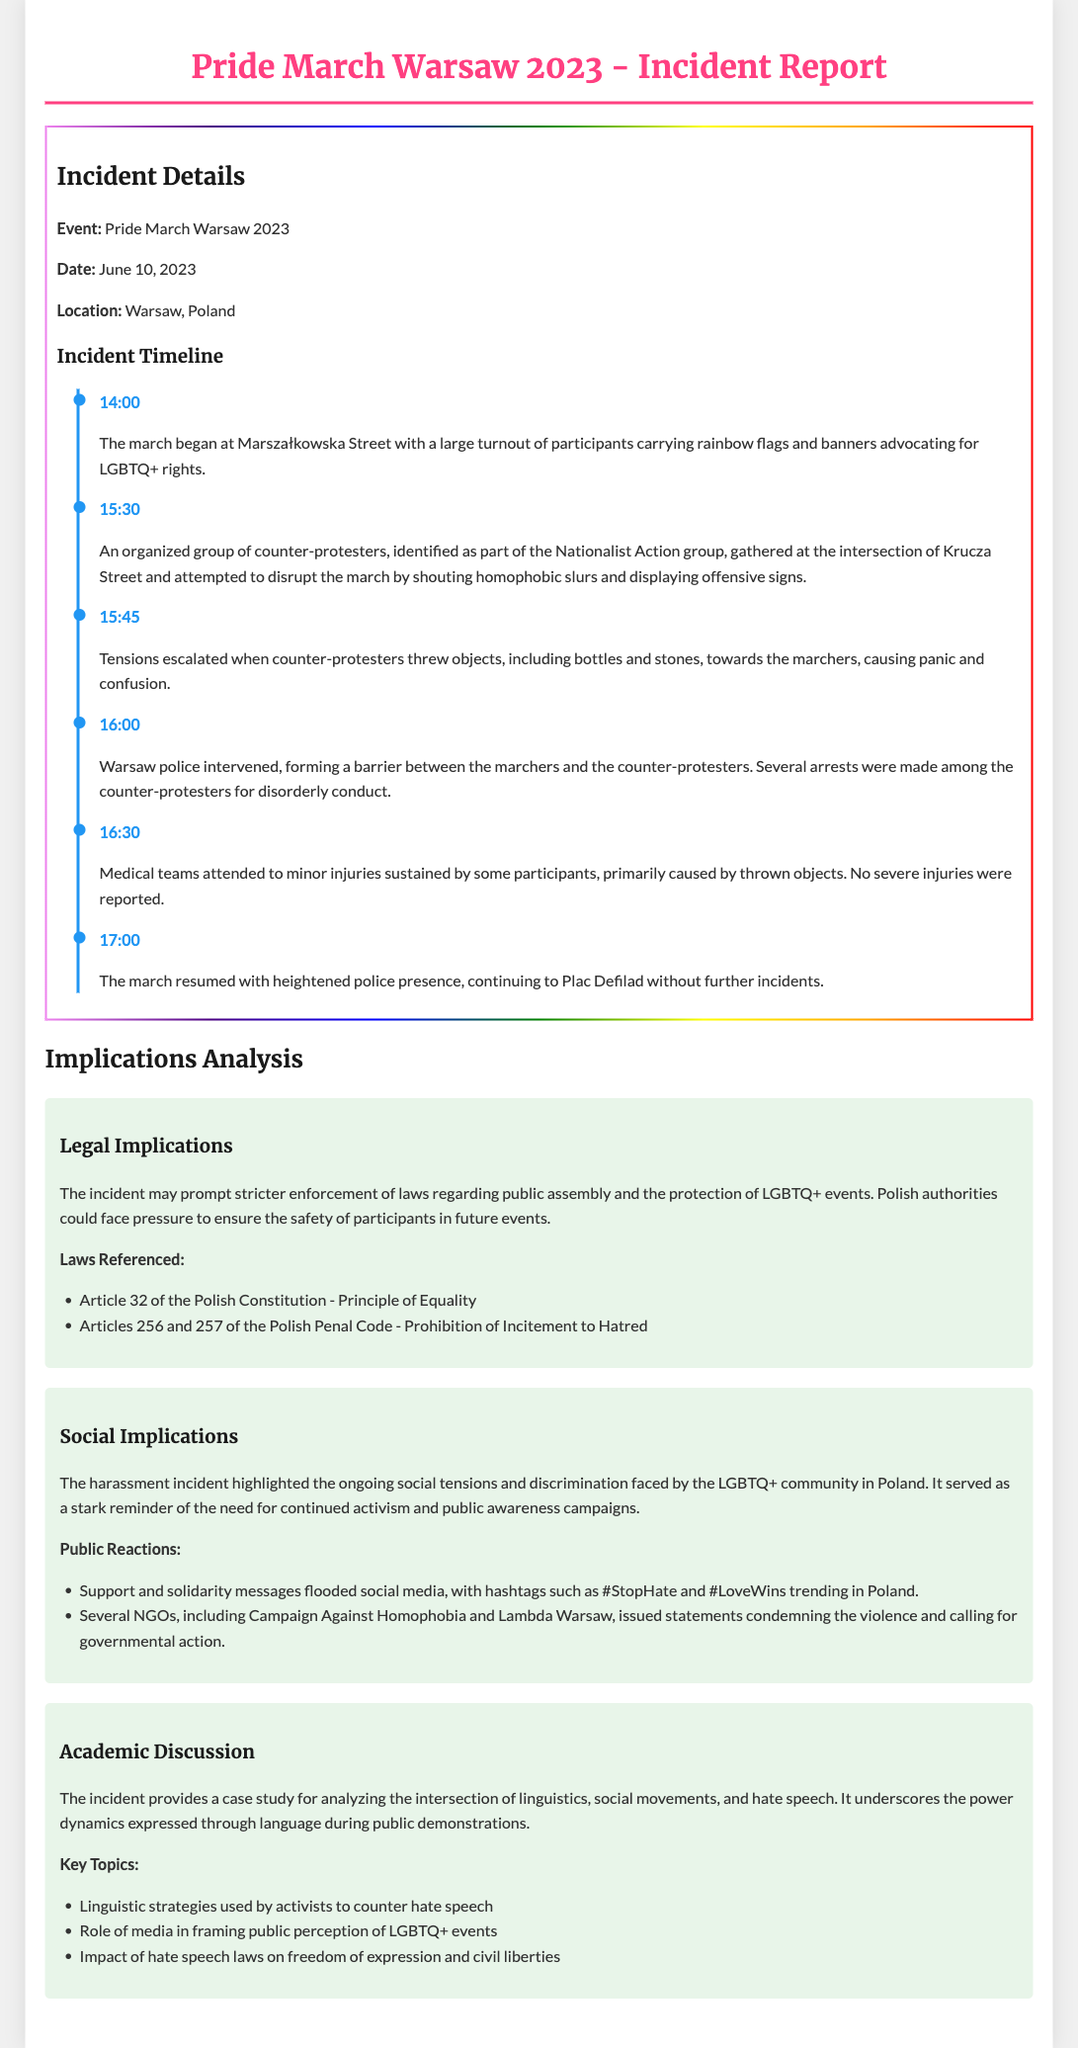What event is documented? The document details a specific event which is the Pride March in Warsaw, 2023.
Answer: Pride March Warsaw 2023 When did the incident occur? The document specifies the date of the incident involving harassment during the event.
Answer: June 10, 2023 What group was identified as counter-protesters? The report names a specific group involved in the counter-protests.
Answer: Nationalist Action What time did the police intervene? The document provides a specific time when police took action to separate the groups.
Answer: 16:00 What injuries were reported? The report indicates the type of injuries sustained by participants during the incident.
Answer: Minor injuries What legal article emphasizes equality? The document mentions a particular article from the Polish Constitution related to equality in its legal implications.
Answer: Article 32 What was a trending hashtag following the incident? The document lists a social media hashtag that gained popularity after the harassment incident.
Answer: #StopHate Which NGO condemned the violence? The report names a specific non-governmental organization that issued statements in response to the incident.
Answer: Campaign Against Homophobia What key topic relates to hate speech laws? The document discusses a significant academic topic connected to the impact of hate speech laws on civil liberties.
Answer: Freedom of expression 